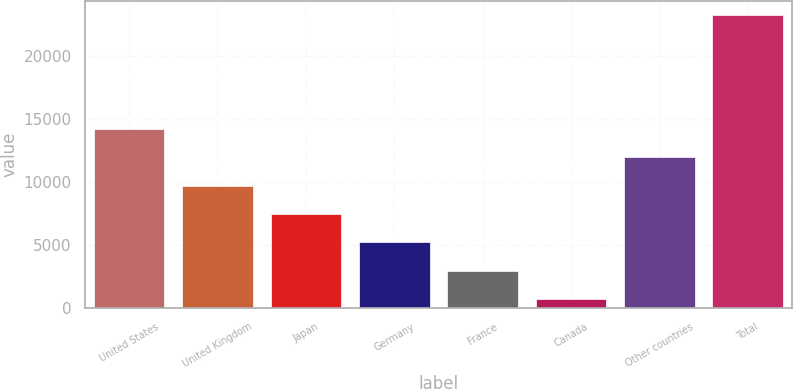<chart> <loc_0><loc_0><loc_500><loc_500><bar_chart><fcel>United States<fcel>United Kingdom<fcel>Japan<fcel>Germany<fcel>France<fcel>Canada<fcel>Other countries<fcel>Total<nl><fcel>14246<fcel>9743<fcel>7491.5<fcel>5240<fcel>2988.5<fcel>737<fcel>11994.5<fcel>23252<nl></chart> 